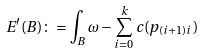Convert formula to latex. <formula><loc_0><loc_0><loc_500><loc_500>E ^ { \prime } ( B ) \colon = \int _ { B } \omega - \sum _ { i = 0 } ^ { k } c ( p _ { ( i + 1 ) i } )</formula> 